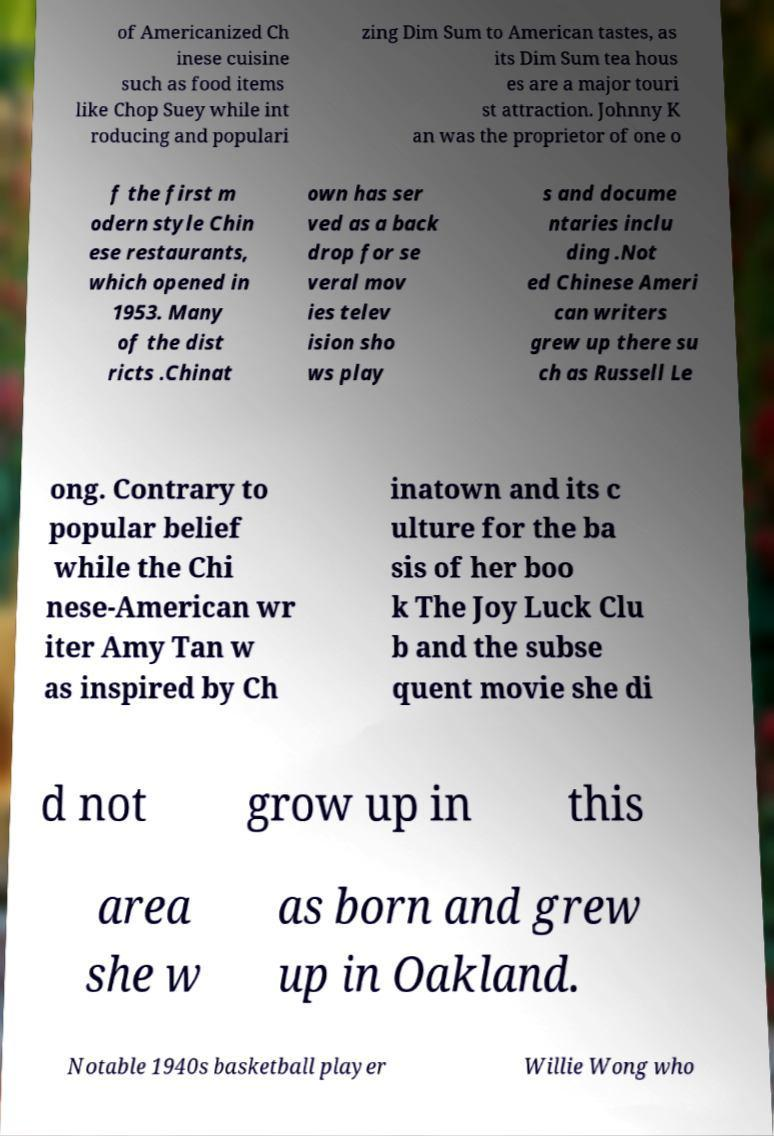There's text embedded in this image that I need extracted. Can you transcribe it verbatim? of Americanized Ch inese cuisine such as food items like Chop Suey while int roducing and populari zing Dim Sum to American tastes, as its Dim Sum tea hous es are a major touri st attraction. Johnny K an was the proprietor of one o f the first m odern style Chin ese restaurants, which opened in 1953. Many of the dist ricts .Chinat own has ser ved as a back drop for se veral mov ies telev ision sho ws play s and docume ntaries inclu ding .Not ed Chinese Ameri can writers grew up there su ch as Russell Le ong. Contrary to popular belief while the Chi nese-American wr iter Amy Tan w as inspired by Ch inatown and its c ulture for the ba sis of her boo k The Joy Luck Clu b and the subse quent movie she di d not grow up in this area she w as born and grew up in Oakland. Notable 1940s basketball player Willie Wong who 